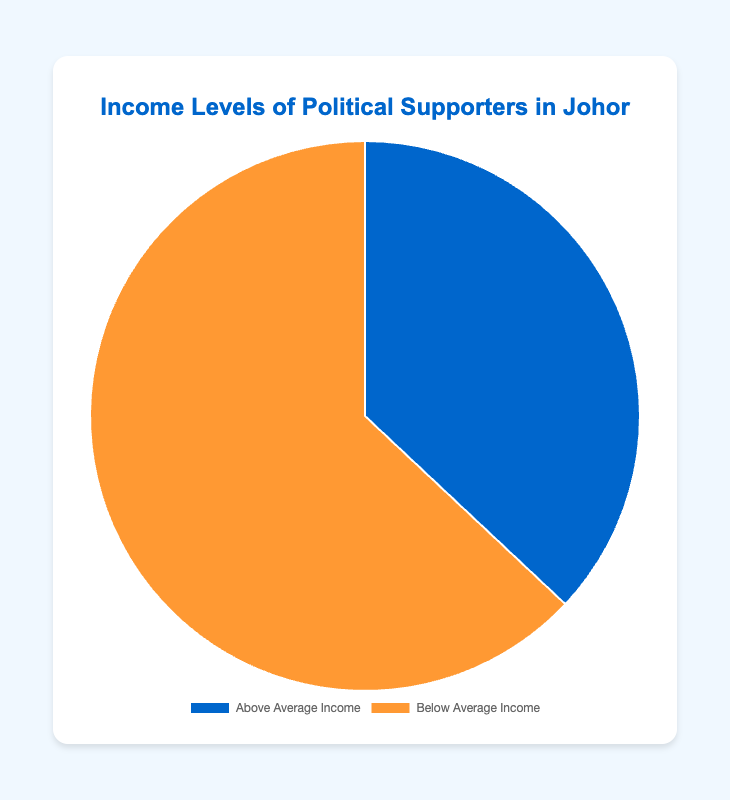What's the percentage of political supporters with below-average income? Looking at the pie chart, the slice indicating "Below Average Income" shows its percentage as 63%.
Answer: 63% Which group has a higher percentage, political supporters with above-average income or below-average income? By comparing the slices in the pie chart, "Below Average Income" has 63%, which is higher than "Above Average Income" with 37%.
Answer: Below-average income What is the difference in percentage points between above-average income and below-average income political supporters? The pie chart shows that "Below Average Income" is 63% and "Above Average Income" is 37%. The difference is 63% - 37% = 26%.
Answer: 26% What fraction of political supporters in Johor have above-average income? According to the chart, 37% of political supporters have above-average income, which can be expressed as 37/100 or 0.37.
Answer: 0.37 If there are 1000 political supporters surveyed, how many supporters have below-average income? If 63% of 1000 political supporters have below-average income, then 63/100 * 1000 = 630 supporters have below-average income.
Answer: 630 What is the combined percentage of political supporters with both above-average and below-average incomes? The sum of the percentages shown for above-average income (37%) and below-average income (63%) is 37% + 63% = 100%.
Answer: 100% What color represents the above-average income group in the chart? The visual representation of the above-average income group is marked with a blue color in the pie chart.
Answer: Blue If the distribution were to change such that above-average income supporters increased by 10%, what would the new percentage be? Currently, above-average income supporters are at 37%. If they increased by 10%, the new percentage would be 37% + 10% = 47%.
Answer: 47% What is the ratio of below-average income supporters to above-average income supporters? The percentages are 63% for below-average income and 37% for above-average income. The ratio is therefore 63:37, which simplifies approximately to 1.7:1.
Answer: 1.7:1 